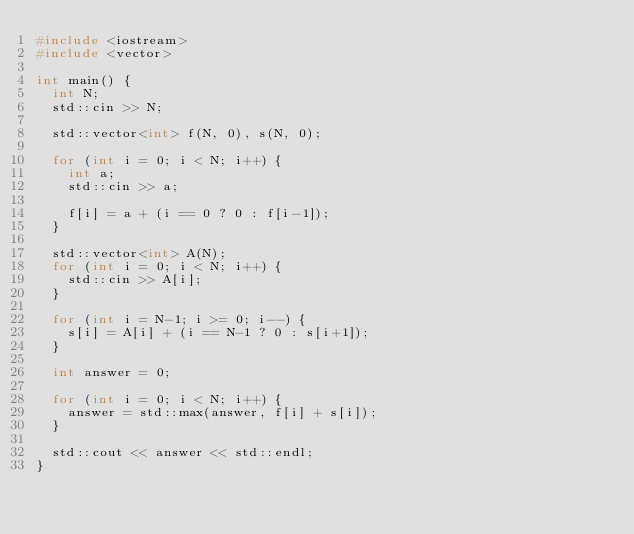<code> <loc_0><loc_0><loc_500><loc_500><_C++_>#include <iostream>
#include <vector>

int main() {
  int N;
  std::cin >> N;

  std::vector<int> f(N, 0), s(N, 0);

  for (int i = 0; i < N; i++) {
    int a;
    std::cin >> a;

    f[i] = a + (i == 0 ? 0 : f[i-1]);
  }

  std::vector<int> A(N);
  for (int i = 0; i < N; i++) {
    std::cin >> A[i];
  }

  for (int i = N-1; i >= 0; i--) {
    s[i] = A[i] + (i == N-1 ? 0 : s[i+1]);
  }

  int answer = 0;

  for (int i = 0; i < N; i++) {
    answer = std::max(answer, f[i] + s[i]);
  }

  std::cout << answer << std::endl;
}
</code> 